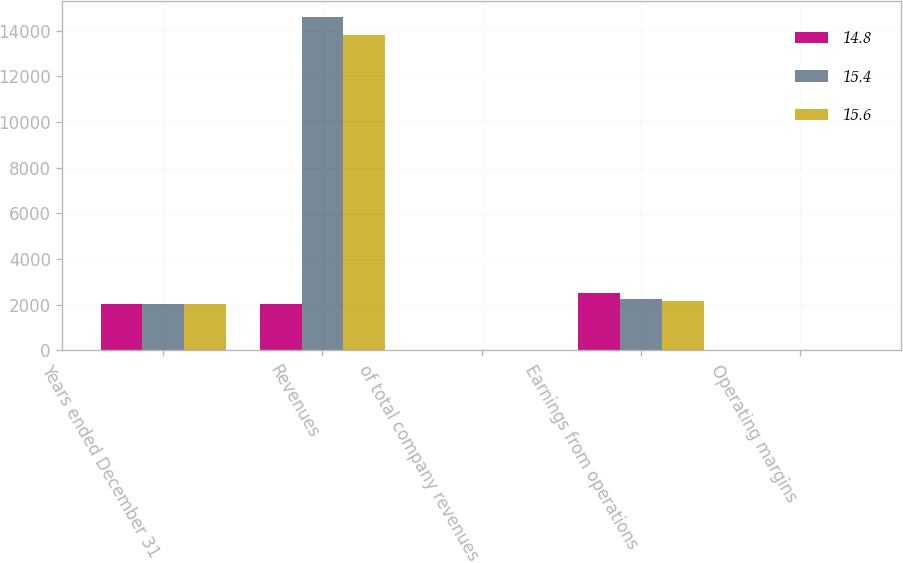<chart> <loc_0><loc_0><loc_500><loc_500><stacked_bar_chart><ecel><fcel>Years ended December 31<fcel>Revenues<fcel>of total company revenues<fcel>Earnings from operations<fcel>Operating margins<nl><fcel>14.8<fcel>2018<fcel>2016.5<fcel>17<fcel>2522<fcel>14.8<nl><fcel>15.4<fcel>2017<fcel>14581<fcel>16<fcel>2246<fcel>15.4<nl><fcel>15.6<fcel>2016<fcel>13819<fcel>15<fcel>2159<fcel>15.6<nl></chart> 